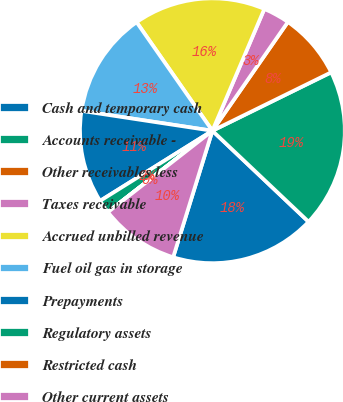<chart> <loc_0><loc_0><loc_500><loc_500><pie_chart><fcel>Cash and temporary cash<fcel>Accounts receivable -<fcel>Other receivables less<fcel>Taxes receivable<fcel>Accrued unbilled revenue<fcel>Fuel oil gas in storage<fcel>Prepayments<fcel>Regulatory assets<fcel>Restricted cash<fcel>Other current assets<nl><fcel>17.73%<fcel>19.34%<fcel>8.07%<fcel>3.24%<fcel>16.12%<fcel>12.9%<fcel>11.29%<fcel>1.63%<fcel>0.02%<fcel>9.68%<nl></chart> 